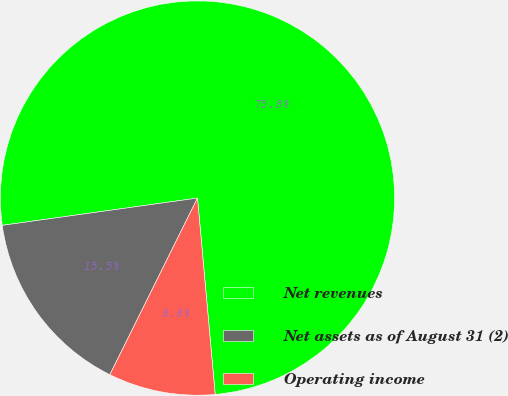<chart> <loc_0><loc_0><loc_500><loc_500><pie_chart><fcel>Net revenues<fcel>Net assets as of August 31 (2)<fcel>Operating income<nl><fcel>75.78%<fcel>15.46%<fcel>8.76%<nl></chart> 